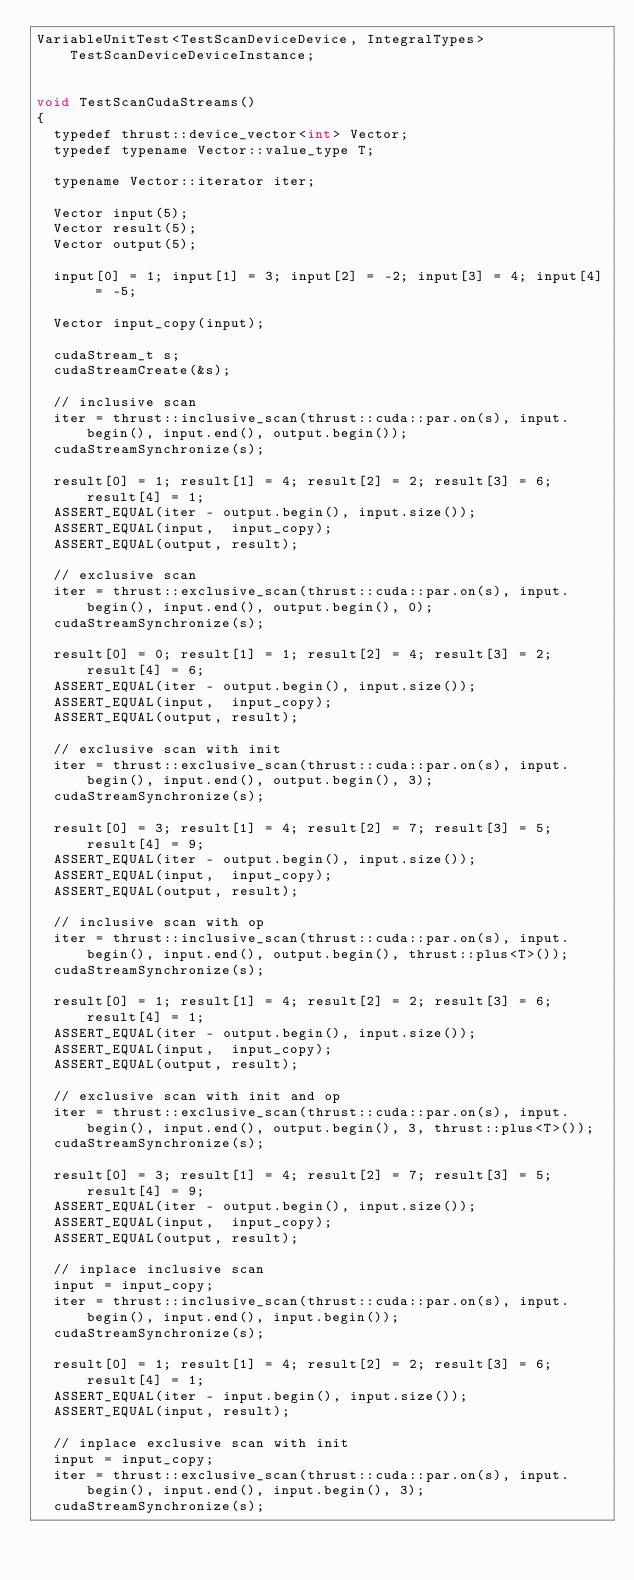Convert code to text. <code><loc_0><loc_0><loc_500><loc_500><_Cuda_>VariableUnitTest<TestScanDeviceDevice, IntegralTypes> TestScanDeviceDeviceInstance;


void TestScanCudaStreams()
{
  typedef thrust::device_vector<int> Vector;
  typedef typename Vector::value_type T;
  
  typename Vector::iterator iter;

  Vector input(5);
  Vector result(5);
  Vector output(5);

  input[0] = 1; input[1] = 3; input[2] = -2; input[3] = 4; input[4] = -5;

  Vector input_copy(input);

  cudaStream_t s;
  cudaStreamCreate(&s);

  // inclusive scan
  iter = thrust::inclusive_scan(thrust::cuda::par.on(s), input.begin(), input.end(), output.begin());
  cudaStreamSynchronize(s);

  result[0] = 1; result[1] = 4; result[2] = 2; result[3] = 6; result[4] = 1;
  ASSERT_EQUAL(iter - output.begin(), input.size());
  ASSERT_EQUAL(input,  input_copy);
  ASSERT_EQUAL(output, result);
  
  // exclusive scan
  iter = thrust::exclusive_scan(thrust::cuda::par.on(s), input.begin(), input.end(), output.begin(), 0);
  cudaStreamSynchronize(s);

  result[0] = 0; result[1] = 1; result[2] = 4; result[3] = 2; result[4] = 6;
  ASSERT_EQUAL(iter - output.begin(), input.size());
  ASSERT_EQUAL(input,  input_copy);
  ASSERT_EQUAL(output, result);
  
  // exclusive scan with init
  iter = thrust::exclusive_scan(thrust::cuda::par.on(s), input.begin(), input.end(), output.begin(), 3);
  cudaStreamSynchronize(s);

  result[0] = 3; result[1] = 4; result[2] = 7; result[3] = 5; result[4] = 9;
  ASSERT_EQUAL(iter - output.begin(), input.size());
  ASSERT_EQUAL(input,  input_copy);
  ASSERT_EQUAL(output, result);
  
  // inclusive scan with op
  iter = thrust::inclusive_scan(thrust::cuda::par.on(s), input.begin(), input.end(), output.begin(), thrust::plus<T>());
  cudaStreamSynchronize(s);

  result[0] = 1; result[1] = 4; result[2] = 2; result[3] = 6; result[4] = 1;
  ASSERT_EQUAL(iter - output.begin(), input.size());
  ASSERT_EQUAL(input,  input_copy);
  ASSERT_EQUAL(output, result);

  // exclusive scan with init and op
  iter = thrust::exclusive_scan(thrust::cuda::par.on(s), input.begin(), input.end(), output.begin(), 3, thrust::plus<T>());
  cudaStreamSynchronize(s);

  result[0] = 3; result[1] = 4; result[2] = 7; result[3] = 5; result[4] = 9;
  ASSERT_EQUAL(iter - output.begin(), input.size());
  ASSERT_EQUAL(input,  input_copy);
  ASSERT_EQUAL(output, result);

  // inplace inclusive scan
  input = input_copy;
  iter = thrust::inclusive_scan(thrust::cuda::par.on(s), input.begin(), input.end(), input.begin());
  cudaStreamSynchronize(s);

  result[0] = 1; result[1] = 4; result[2] = 2; result[3] = 6; result[4] = 1;
  ASSERT_EQUAL(iter - input.begin(), input.size());
  ASSERT_EQUAL(input, result);

  // inplace exclusive scan with init
  input = input_copy;
  iter = thrust::exclusive_scan(thrust::cuda::par.on(s), input.begin(), input.end(), input.begin(), 3);
  cudaStreamSynchronize(s);
</code> 